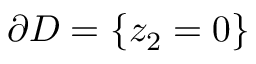Convert formula to latex. <formula><loc_0><loc_0><loc_500><loc_500>\partial D = \{ z _ { 2 } = 0 \}</formula> 